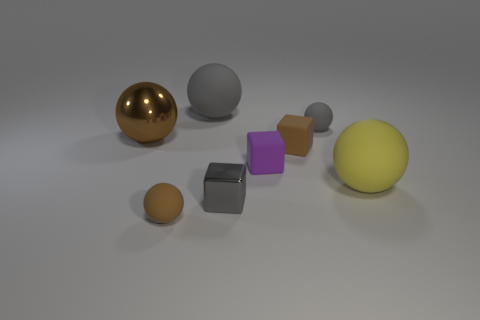Are there more small gray rubber spheres than balls?
Provide a short and direct response. No. There is a metallic thing to the right of the gray rubber object that is on the left side of the tiny gray rubber thing; how many tiny rubber balls are on the left side of it?
Your answer should be compact. 1. The small purple matte object is what shape?
Your answer should be very brief. Cube. How many other objects are the same material as the large yellow ball?
Offer a terse response. 5. Does the brown metallic thing have the same size as the yellow object?
Offer a terse response. Yes. There is a large gray object that is to the left of the purple object; what shape is it?
Give a very brief answer. Sphere. What color is the shiny object to the right of the large matte object behind the large shiny sphere?
Offer a terse response. Gray. There is a brown rubber object to the left of the small brown matte cube; is its shape the same as the small gray object right of the small purple cube?
Provide a short and direct response. Yes. The other rubber thing that is the same size as the yellow thing is what shape?
Ensure brevity in your answer.  Sphere. The cube that is the same material as the large brown object is what color?
Keep it short and to the point. Gray. 